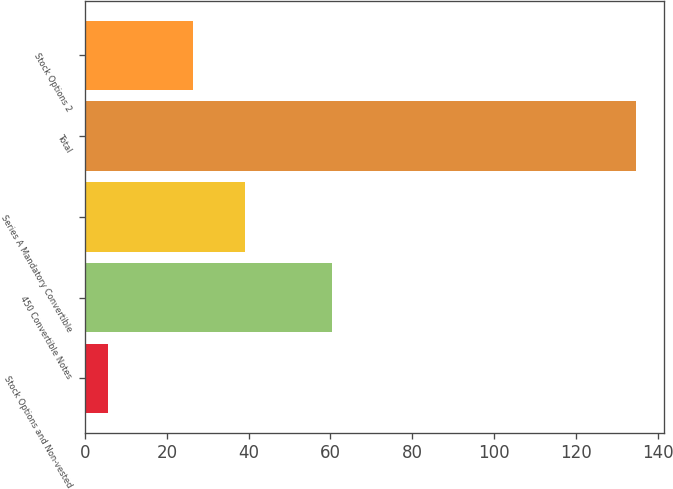Convert chart. <chart><loc_0><loc_0><loc_500><loc_500><bar_chart><fcel>Stock Options and Non-vested<fcel>450 Convertible Notes<fcel>Series A Mandatory Convertible<fcel>Total<fcel>Stock Options 2<nl><fcel>5.5<fcel>60.3<fcel>39.23<fcel>134.8<fcel>26.3<nl></chart> 